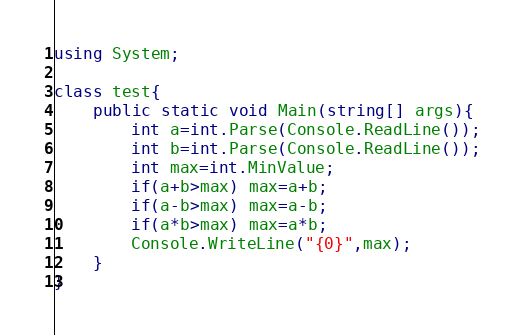Convert code to text. <code><loc_0><loc_0><loc_500><loc_500><_C#_>using System;

class test{
    public static void Main(string[] args){
        int a=int.Parse(Console.ReadLine());
        int b=int.Parse(Console.ReadLine());
        int max=int.MinValue;
        if(a+b>max) max=a+b;
        if(a-b>max) max=a-b;
        if(a*b>max) max=a*b;
        Console.WriteLine("{0}",max);
    }
}</code> 